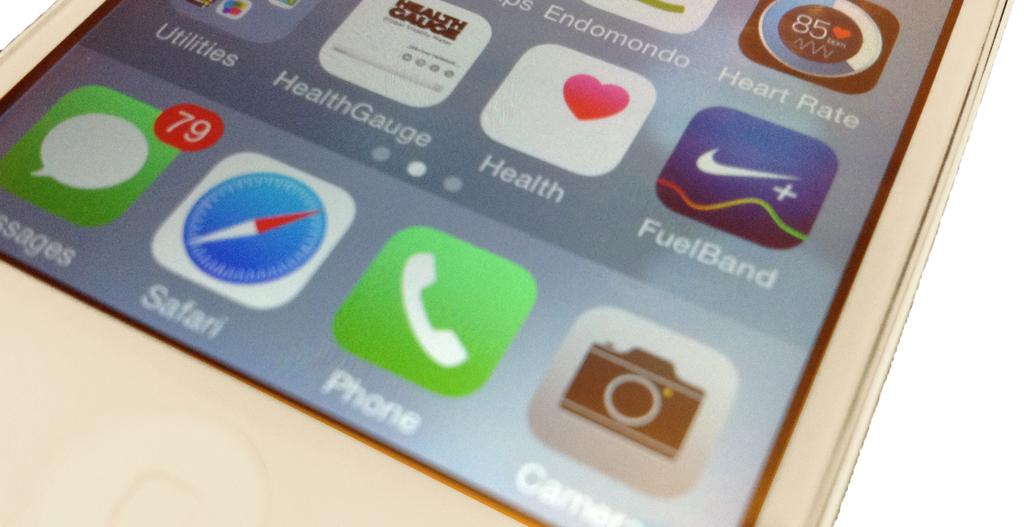<image>
Render a clear and concise summary of the photo. The app on the phone has 79 messages. 